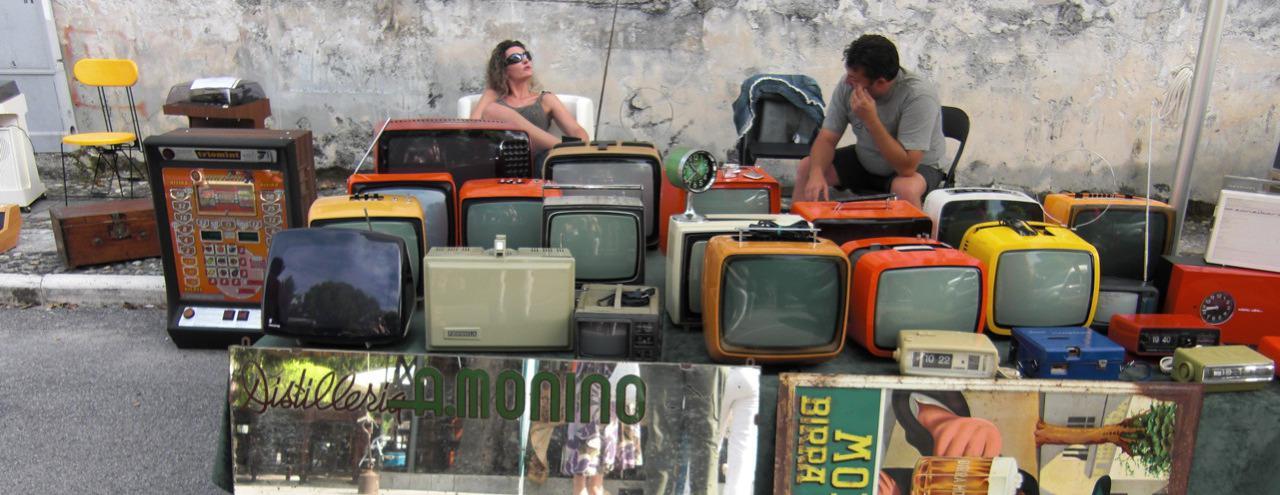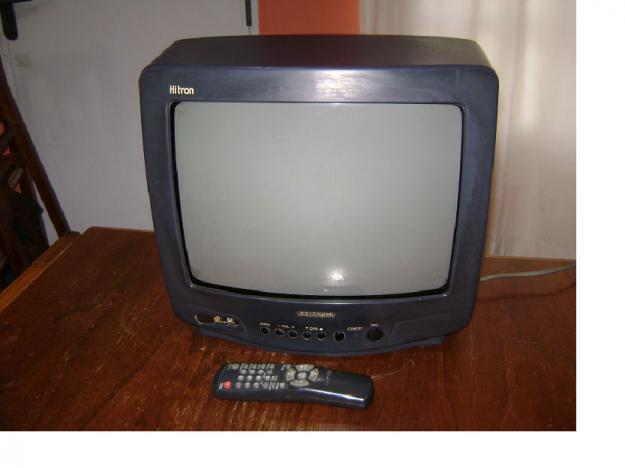The first image is the image on the left, the second image is the image on the right. Considering the images on both sides, is "In one of the images, there is only one television." valid? Answer yes or no. Yes. The first image is the image on the left, the second image is the image on the right. Given the left and right images, does the statement "Multiple colorful tv's are stacked on each other" hold true? Answer yes or no. No. 